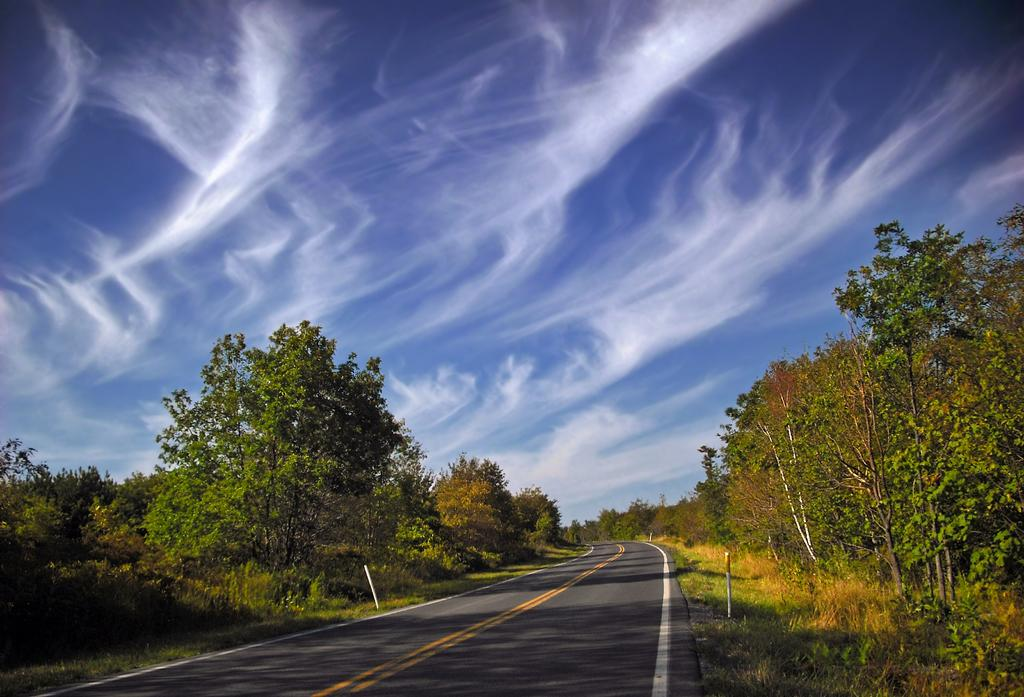Where was the image taken? The image was taken on a road. What can be seen on the road in the image? There are markings on the road in the image. What type of vegetation is visible beside the road? There are trees beside the road. What is present on the ground in the image? Grass is present on the ground. What is visible at the top of the image? The sky is visible at the top of the image. Can you see any chalk drawings on the road in the image? There are no chalk drawings visible on the road in the image. Are there any goldfish swimming in the grass in the image? There are no goldfish present in the image, and goldfish cannot swim in grass. 